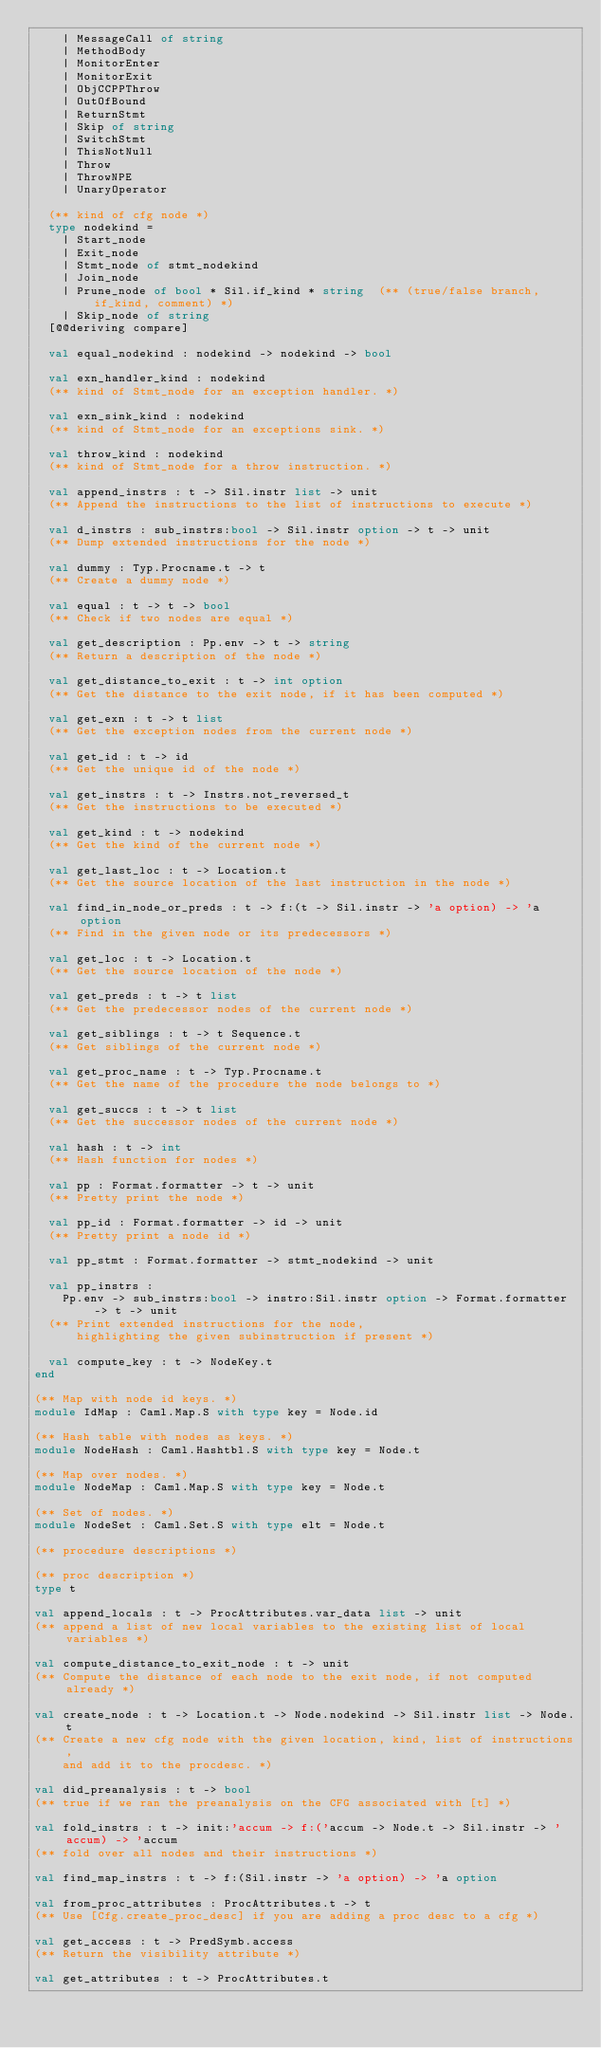Convert code to text. <code><loc_0><loc_0><loc_500><loc_500><_OCaml_>    | MessageCall of string
    | MethodBody
    | MonitorEnter
    | MonitorExit
    | ObjCCPPThrow
    | OutOfBound
    | ReturnStmt
    | Skip of string
    | SwitchStmt
    | ThisNotNull
    | Throw
    | ThrowNPE
    | UnaryOperator

  (** kind of cfg node *)
  type nodekind =
    | Start_node
    | Exit_node
    | Stmt_node of stmt_nodekind
    | Join_node
    | Prune_node of bool * Sil.if_kind * string  (** (true/false branch, if_kind, comment) *)
    | Skip_node of string
  [@@deriving compare]

  val equal_nodekind : nodekind -> nodekind -> bool

  val exn_handler_kind : nodekind
  (** kind of Stmt_node for an exception handler. *)

  val exn_sink_kind : nodekind
  (** kind of Stmt_node for an exceptions sink. *)

  val throw_kind : nodekind
  (** kind of Stmt_node for a throw instruction. *)

  val append_instrs : t -> Sil.instr list -> unit
  (** Append the instructions to the list of instructions to execute *)

  val d_instrs : sub_instrs:bool -> Sil.instr option -> t -> unit
  (** Dump extended instructions for the node *)

  val dummy : Typ.Procname.t -> t
  (** Create a dummy node *)

  val equal : t -> t -> bool
  (** Check if two nodes are equal *)

  val get_description : Pp.env -> t -> string
  (** Return a description of the node *)

  val get_distance_to_exit : t -> int option
  (** Get the distance to the exit node, if it has been computed *)

  val get_exn : t -> t list
  (** Get the exception nodes from the current node *)

  val get_id : t -> id
  (** Get the unique id of the node *)

  val get_instrs : t -> Instrs.not_reversed_t
  (** Get the instructions to be executed *)

  val get_kind : t -> nodekind
  (** Get the kind of the current node *)

  val get_last_loc : t -> Location.t
  (** Get the source location of the last instruction in the node *)

  val find_in_node_or_preds : t -> f:(t -> Sil.instr -> 'a option) -> 'a option
  (** Find in the given node or its predecessors *)

  val get_loc : t -> Location.t
  (** Get the source location of the node *)

  val get_preds : t -> t list
  (** Get the predecessor nodes of the current node *)

  val get_siblings : t -> t Sequence.t
  (** Get siblings of the current node *)

  val get_proc_name : t -> Typ.Procname.t
  (** Get the name of the procedure the node belongs to *)

  val get_succs : t -> t list
  (** Get the successor nodes of the current node *)

  val hash : t -> int
  (** Hash function for nodes *)

  val pp : Format.formatter -> t -> unit
  (** Pretty print the node *)

  val pp_id : Format.formatter -> id -> unit
  (** Pretty print a node id *)

  val pp_stmt : Format.formatter -> stmt_nodekind -> unit

  val pp_instrs :
    Pp.env -> sub_instrs:bool -> instro:Sil.instr option -> Format.formatter -> t -> unit
  (** Print extended instructions for the node,
      highlighting the given subinstruction if present *)

  val compute_key : t -> NodeKey.t
end

(** Map with node id keys. *)
module IdMap : Caml.Map.S with type key = Node.id

(** Hash table with nodes as keys. *)
module NodeHash : Caml.Hashtbl.S with type key = Node.t

(** Map over nodes. *)
module NodeMap : Caml.Map.S with type key = Node.t

(** Set of nodes. *)
module NodeSet : Caml.Set.S with type elt = Node.t

(** procedure descriptions *)

(** proc description *)
type t

val append_locals : t -> ProcAttributes.var_data list -> unit
(** append a list of new local variables to the existing list of local variables *)

val compute_distance_to_exit_node : t -> unit
(** Compute the distance of each node to the exit node, if not computed already *)

val create_node : t -> Location.t -> Node.nodekind -> Sil.instr list -> Node.t
(** Create a new cfg node with the given location, kind, list of instructions,
    and add it to the procdesc. *)

val did_preanalysis : t -> bool
(** true if we ran the preanalysis on the CFG associated with [t] *)

val fold_instrs : t -> init:'accum -> f:('accum -> Node.t -> Sil.instr -> 'accum) -> 'accum
(** fold over all nodes and their instructions *)

val find_map_instrs : t -> f:(Sil.instr -> 'a option) -> 'a option

val from_proc_attributes : ProcAttributes.t -> t
(** Use [Cfg.create_proc_desc] if you are adding a proc desc to a cfg *)

val get_access : t -> PredSymb.access
(** Return the visibility attribute *)

val get_attributes : t -> ProcAttributes.t</code> 